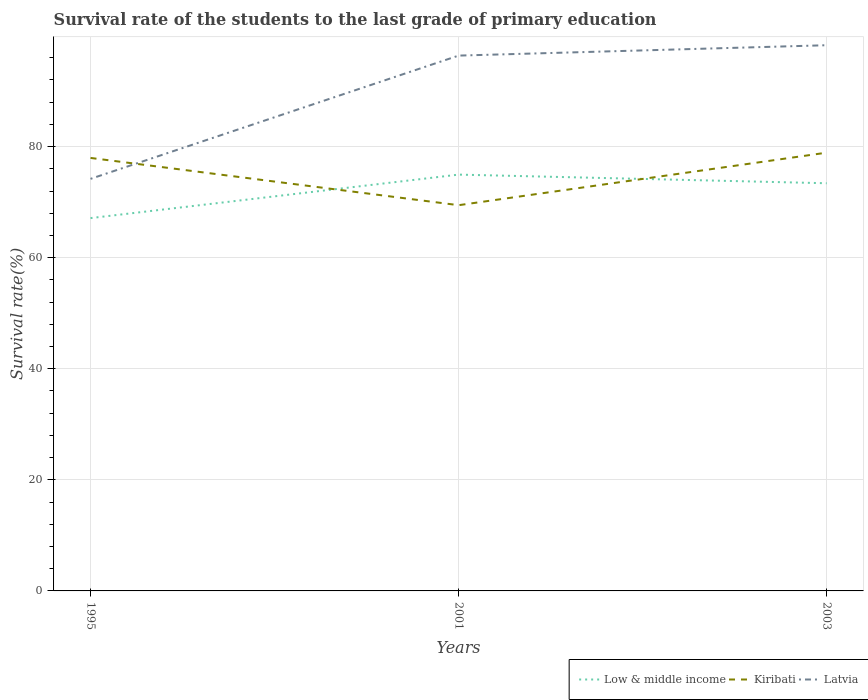How many different coloured lines are there?
Your answer should be compact. 3. Does the line corresponding to Kiribati intersect with the line corresponding to Latvia?
Your response must be concise. Yes. Across all years, what is the maximum survival rate of the students in Low & middle income?
Your answer should be very brief. 67.12. In which year was the survival rate of the students in Low & middle income maximum?
Provide a succinct answer. 1995. What is the total survival rate of the students in Kiribati in the graph?
Keep it short and to the point. -9.46. What is the difference between the highest and the second highest survival rate of the students in Kiribati?
Make the answer very short. 9.46. What is the difference between two consecutive major ticks on the Y-axis?
Provide a succinct answer. 20. Does the graph contain grids?
Keep it short and to the point. Yes. How many legend labels are there?
Give a very brief answer. 3. What is the title of the graph?
Provide a succinct answer. Survival rate of the students to the last grade of primary education. Does "Swaziland" appear as one of the legend labels in the graph?
Make the answer very short. No. What is the label or title of the Y-axis?
Make the answer very short. Survival rate(%). What is the Survival rate(%) in Low & middle income in 1995?
Your response must be concise. 67.12. What is the Survival rate(%) of Kiribati in 1995?
Ensure brevity in your answer.  77.96. What is the Survival rate(%) of Latvia in 1995?
Provide a succinct answer. 74.19. What is the Survival rate(%) of Low & middle income in 2001?
Give a very brief answer. 74.95. What is the Survival rate(%) of Kiribati in 2001?
Your answer should be compact. 69.45. What is the Survival rate(%) of Latvia in 2001?
Your answer should be compact. 96.38. What is the Survival rate(%) of Low & middle income in 2003?
Your answer should be compact. 73.4. What is the Survival rate(%) of Kiribati in 2003?
Your answer should be compact. 78.91. What is the Survival rate(%) in Latvia in 2003?
Your answer should be very brief. 98.25. Across all years, what is the maximum Survival rate(%) in Low & middle income?
Your answer should be very brief. 74.95. Across all years, what is the maximum Survival rate(%) of Kiribati?
Provide a short and direct response. 78.91. Across all years, what is the maximum Survival rate(%) of Latvia?
Make the answer very short. 98.25. Across all years, what is the minimum Survival rate(%) of Low & middle income?
Ensure brevity in your answer.  67.12. Across all years, what is the minimum Survival rate(%) in Kiribati?
Your answer should be compact. 69.45. Across all years, what is the minimum Survival rate(%) of Latvia?
Give a very brief answer. 74.19. What is the total Survival rate(%) of Low & middle income in the graph?
Offer a terse response. 215.47. What is the total Survival rate(%) in Kiribati in the graph?
Provide a succinct answer. 226.31. What is the total Survival rate(%) in Latvia in the graph?
Give a very brief answer. 268.81. What is the difference between the Survival rate(%) in Low & middle income in 1995 and that in 2001?
Give a very brief answer. -7.83. What is the difference between the Survival rate(%) in Kiribati in 1995 and that in 2001?
Make the answer very short. 8.51. What is the difference between the Survival rate(%) in Latvia in 1995 and that in 2001?
Ensure brevity in your answer.  -22.19. What is the difference between the Survival rate(%) in Low & middle income in 1995 and that in 2003?
Make the answer very short. -6.28. What is the difference between the Survival rate(%) in Kiribati in 1995 and that in 2003?
Ensure brevity in your answer.  -0.95. What is the difference between the Survival rate(%) in Latvia in 1995 and that in 2003?
Give a very brief answer. -24.06. What is the difference between the Survival rate(%) of Low & middle income in 2001 and that in 2003?
Ensure brevity in your answer.  1.56. What is the difference between the Survival rate(%) in Kiribati in 2001 and that in 2003?
Your response must be concise. -9.46. What is the difference between the Survival rate(%) of Latvia in 2001 and that in 2003?
Provide a succinct answer. -1.87. What is the difference between the Survival rate(%) of Low & middle income in 1995 and the Survival rate(%) of Kiribati in 2001?
Your response must be concise. -2.32. What is the difference between the Survival rate(%) of Low & middle income in 1995 and the Survival rate(%) of Latvia in 2001?
Keep it short and to the point. -29.26. What is the difference between the Survival rate(%) in Kiribati in 1995 and the Survival rate(%) in Latvia in 2001?
Ensure brevity in your answer.  -18.42. What is the difference between the Survival rate(%) of Low & middle income in 1995 and the Survival rate(%) of Kiribati in 2003?
Ensure brevity in your answer.  -11.78. What is the difference between the Survival rate(%) in Low & middle income in 1995 and the Survival rate(%) in Latvia in 2003?
Offer a terse response. -31.13. What is the difference between the Survival rate(%) in Kiribati in 1995 and the Survival rate(%) in Latvia in 2003?
Give a very brief answer. -20.29. What is the difference between the Survival rate(%) in Low & middle income in 2001 and the Survival rate(%) in Kiribati in 2003?
Your answer should be compact. -3.95. What is the difference between the Survival rate(%) in Low & middle income in 2001 and the Survival rate(%) in Latvia in 2003?
Provide a short and direct response. -23.29. What is the difference between the Survival rate(%) in Kiribati in 2001 and the Survival rate(%) in Latvia in 2003?
Your response must be concise. -28.8. What is the average Survival rate(%) of Low & middle income per year?
Provide a succinct answer. 71.82. What is the average Survival rate(%) of Kiribati per year?
Give a very brief answer. 75.44. What is the average Survival rate(%) in Latvia per year?
Keep it short and to the point. 89.6. In the year 1995, what is the difference between the Survival rate(%) in Low & middle income and Survival rate(%) in Kiribati?
Give a very brief answer. -10.83. In the year 1995, what is the difference between the Survival rate(%) in Low & middle income and Survival rate(%) in Latvia?
Your response must be concise. -7.07. In the year 1995, what is the difference between the Survival rate(%) in Kiribati and Survival rate(%) in Latvia?
Ensure brevity in your answer.  3.77. In the year 2001, what is the difference between the Survival rate(%) of Low & middle income and Survival rate(%) of Kiribati?
Ensure brevity in your answer.  5.51. In the year 2001, what is the difference between the Survival rate(%) in Low & middle income and Survival rate(%) in Latvia?
Your response must be concise. -21.43. In the year 2001, what is the difference between the Survival rate(%) of Kiribati and Survival rate(%) of Latvia?
Your answer should be compact. -26.93. In the year 2003, what is the difference between the Survival rate(%) in Low & middle income and Survival rate(%) in Kiribati?
Offer a terse response. -5.51. In the year 2003, what is the difference between the Survival rate(%) of Low & middle income and Survival rate(%) of Latvia?
Your answer should be compact. -24.85. In the year 2003, what is the difference between the Survival rate(%) of Kiribati and Survival rate(%) of Latvia?
Offer a terse response. -19.34. What is the ratio of the Survival rate(%) of Low & middle income in 1995 to that in 2001?
Your response must be concise. 0.9. What is the ratio of the Survival rate(%) in Kiribati in 1995 to that in 2001?
Your answer should be compact. 1.12. What is the ratio of the Survival rate(%) in Latvia in 1995 to that in 2001?
Your answer should be very brief. 0.77. What is the ratio of the Survival rate(%) of Low & middle income in 1995 to that in 2003?
Your answer should be very brief. 0.91. What is the ratio of the Survival rate(%) in Latvia in 1995 to that in 2003?
Provide a short and direct response. 0.76. What is the ratio of the Survival rate(%) in Low & middle income in 2001 to that in 2003?
Provide a short and direct response. 1.02. What is the ratio of the Survival rate(%) in Kiribati in 2001 to that in 2003?
Your response must be concise. 0.88. What is the ratio of the Survival rate(%) of Latvia in 2001 to that in 2003?
Offer a very short reply. 0.98. What is the difference between the highest and the second highest Survival rate(%) in Low & middle income?
Ensure brevity in your answer.  1.56. What is the difference between the highest and the second highest Survival rate(%) of Kiribati?
Offer a terse response. 0.95. What is the difference between the highest and the second highest Survival rate(%) of Latvia?
Provide a succinct answer. 1.87. What is the difference between the highest and the lowest Survival rate(%) in Low & middle income?
Give a very brief answer. 7.83. What is the difference between the highest and the lowest Survival rate(%) of Kiribati?
Your answer should be compact. 9.46. What is the difference between the highest and the lowest Survival rate(%) of Latvia?
Ensure brevity in your answer.  24.06. 